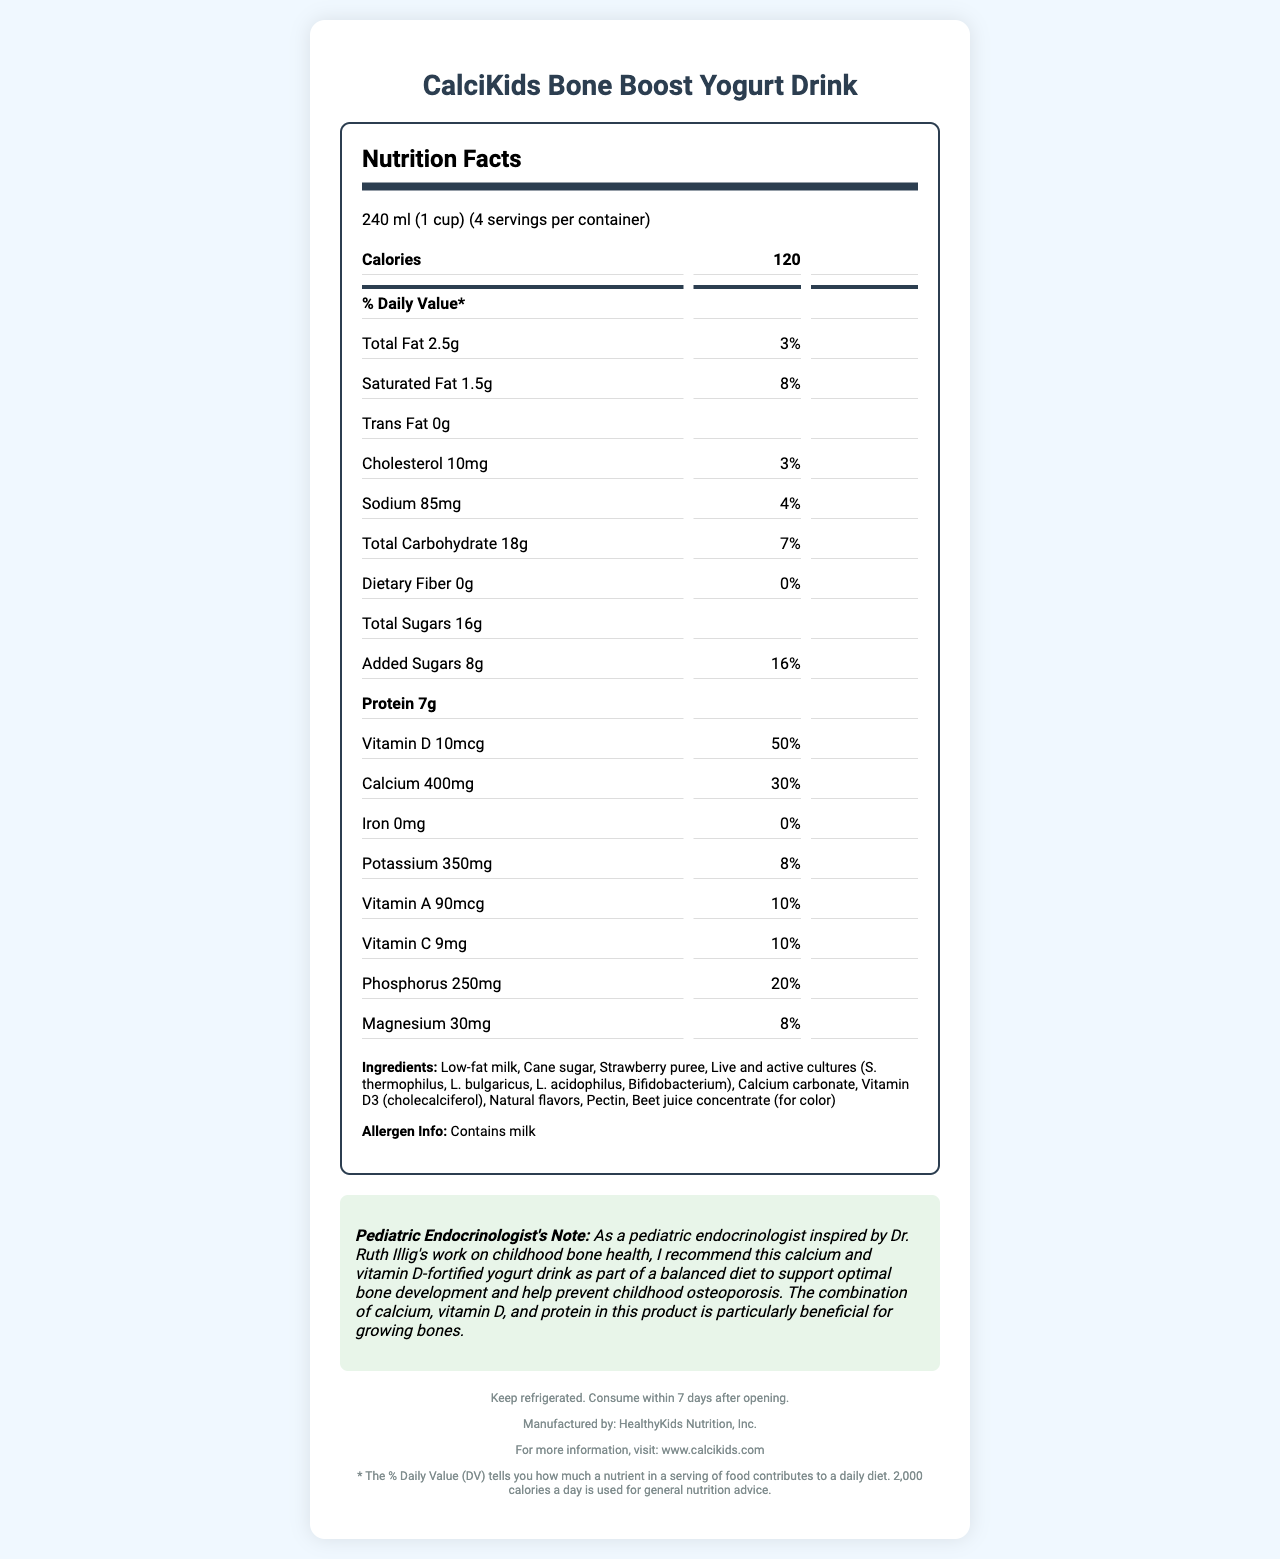what is the product name? The product name is clearly stated at the top of the document.
Answer: CalciKids Bone Boost Yogurt Drink how many servings are in the container? The document specifies that there are 4 servings per container.
Answer: 4 what is the serving size? The serving size is listed as 240 ml (1 cup) in the nutrition facts section.
Answer: 240 ml (1 cup) what is the total number of calories per serving? The nutrition label shows that each serving contains 120 calories.
Answer: 120 how much protein is in one serving of the yogurt drink? The nutrition label indicates that there are 7 grams of protein per serving.
Answer: 7g what are the main ingredients of this yogurt drink? The ingredients are listed under the "Ingredients" section at the bottom of the document.
Answer: Low-fat milk, Cane sugar, Strawberry puree, Live and active cultures (S. thermophilus, L. bulgaricus, L. acidophilus, Bifidobacterium), Calcium carbonate, Vitamin D3 (cholecalciferol), Natural flavors, Pectin, Beet juice concentrate (for color) how much calcium does one serving provide in terms of daily value percentage? The nutrition label indicates that one serving provides 30% of the daily value for calcium.
Answer: 30% which vitamin is present in the highest amount based on daily value percentage? A. Vitamin D B. Vitamin C C. Vitamin A Vitamin D provides 50% of the daily value, which is the highest among the listed vitamins.
Answer: A. Vitamin D how much added sugars are there in one serving? The document shows that there are 8 grams of added sugars per serving.
Answer: 8g what is the daily value percentage for sodium? A. 4% B. 8% C. 3% The daily value percentage for sodium is listed as 4%.
Answer: A. 4% does the product contain any dietary fiber? The nutrition facts label indicates that there is 0 grams of dietary fiber in the product.
Answer: No is there any cholesterol in the yogurt drink? The nutrition information states that there are 10mg of cholesterol per serving, which is 3% of the daily value.
Answer: Yes what is the role of the pediatric endocrinologist note? The pediatric endocrinologist note provides a professional opinion, explaining the product's importance for childhood bone health.
Answer: The note emphasizes the benefits of the yogurt drink in supporting optimal bone development in children and preventing childhood osteoporosis, highlighting its beneficial combination of calcium, vitamin D, and protein. summarize the main nutrition benefits of CalciKids Bone Boost Yogurt Drink. The product focuses on enhancing bone development with significant amounts of calcium, vitamin D, and protein, making it particularly suitable for childhood osteoporosis prevention.
Answer: CalciKids Bone Boost Yogurt Drink is designed to support children's bone health by providing essential nutrients such as calcium (30% DV), vitamin D (50% DV), and protein (7g per serving). The yogurt drink is low in total fat but contains beneficial live and active cultures for digestion. can this product be suitable for someone with a milk allergy? The allergen information clearly states that the product contains milk, making it unsuitable for someone with a milk allergy.
Answer: No 